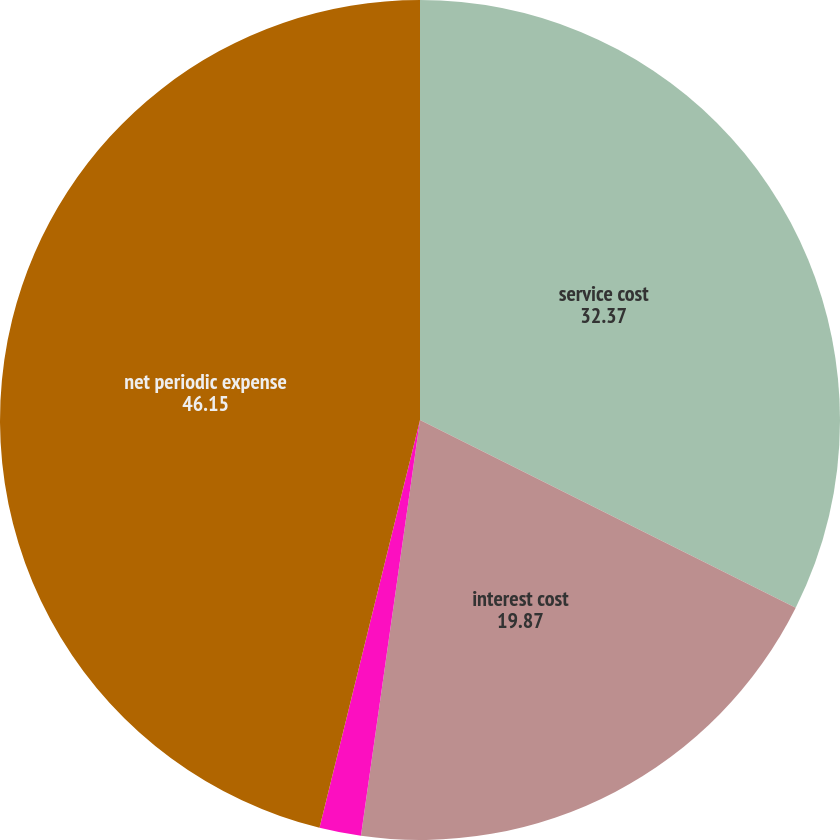Convert chart to OTSL. <chart><loc_0><loc_0><loc_500><loc_500><pie_chart><fcel>service cost<fcel>interest cost<fcel>Amortization of net prior<fcel>net periodic expense<nl><fcel>32.37%<fcel>19.87%<fcel>1.6%<fcel>46.15%<nl></chart> 